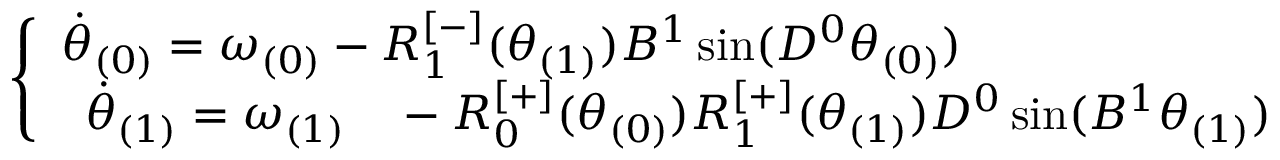<formula> <loc_0><loc_0><loc_500><loc_500>\begin{array} { r } { \left \{ \begin{array} { l l } { \ D o t { \theta } _ { ( 0 ) } = \omega _ { ( 0 ) } - R _ { 1 } ^ { [ - ] } ( \theta _ { ( 1 ) } ) B ^ { 1 } \sin ( D ^ { 0 } \theta _ { ( 0 ) } ) } \\ { \begin{array} { r l } { \ D o t { \theta } _ { ( 1 ) } = \omega _ { ( 1 ) } } & - R _ { 0 } ^ { [ + ] } ( \theta _ { ( 0 ) } ) R _ { 1 } ^ { [ + ] } ( \theta _ { ( 1 ) } ) D ^ { 0 } \sin ( B ^ { 1 } \theta _ { ( 1 ) } ) } \end{array} } \end{array} } \end{array}</formula> 